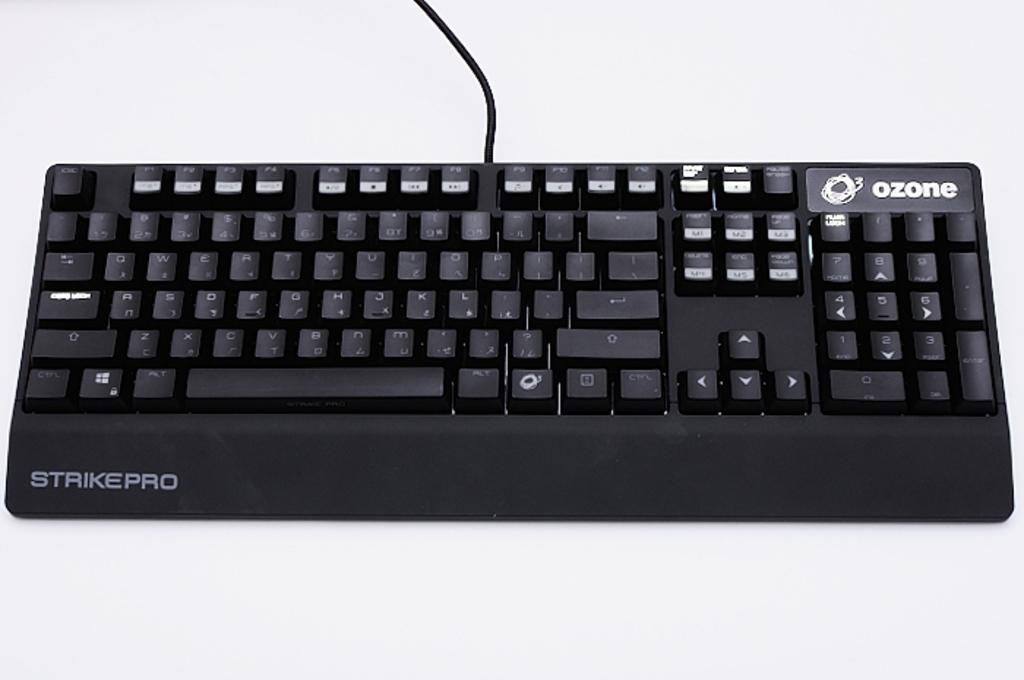What object is the main focus of the image? There is a keyboard in the image. What is the color of the keyboard? The keyboard is black in color. Where is the keyboard located in the image? The keyboard is placed on a table. Does the keyboard have a tail in the image? No, the keyboard does not have a tail in the image, as keyboards do not have tails. 